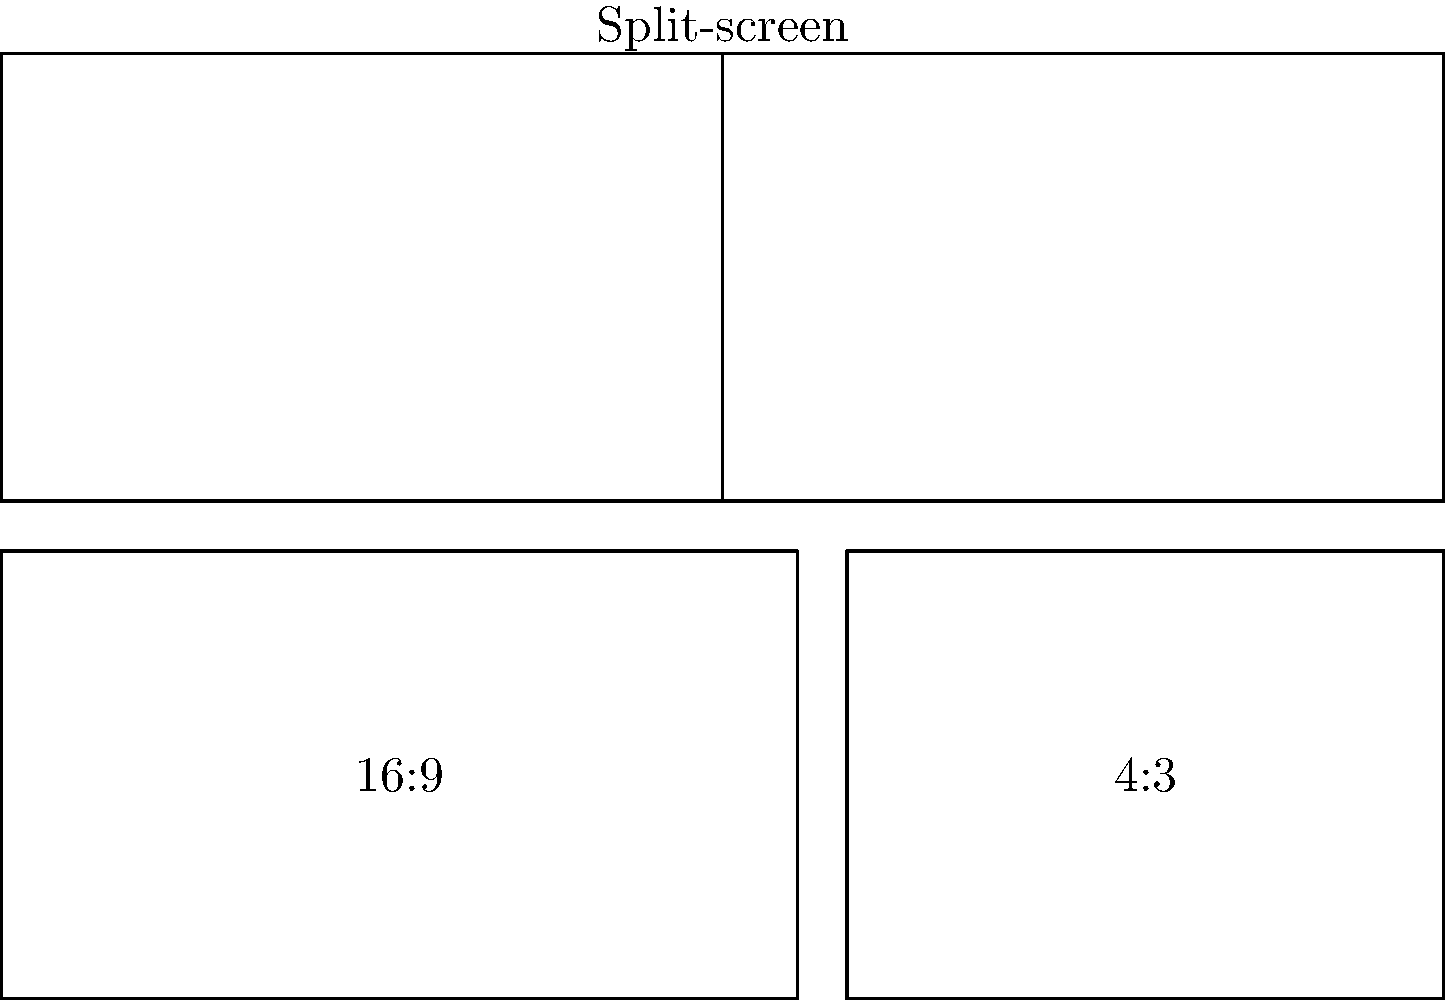In a split-screen composition using both 16:9 and 4:3 aspect ratios, how might the juxtaposition of these formats impact the visual narrative, particularly in an independent film context? Consider the potential for emphasizing character relationships or contrasting environments. To answer this question, let's break down the impact of using different aspect ratios in a split-screen composition:

1. Visual contrast: The 16:9 and 4:3 aspect ratios create a noticeable visual difference, immediately drawing attention to the split-screen composition.

2. Character emphasis: The wider 16:9 format can be used to show a character in a more expansive environment, while the 4:3 format might create a sense of confinement or focus for another character.

3. Temporal juxtaposition: Different aspect ratios can suggest different time periods, with 4:3 potentially indicating a flashback or older footage.

4. Narrative layering: The contrast in aspect ratios can represent different perspectives or realities within the story.

5. Emotional resonance: The wider 16:9 frame might convey a sense of freedom or possibility, while the 4:3 frame could evoke nostalgia or limitation.

6. Compositional balance: The filmmaker must consider how to balance the visual weight of the two different aspect ratios within the frame.

7. Thematic reinforcement: The aspect ratio choices can reinforce themes of duality, conflict, or parallel narratives in the film.

8. Audience engagement: The unique visual presentation encourages active viewing and interpretation from the audience.

9. Technical considerations: The filmmaker must plan for how these different aspect ratios will be integrated in post-production and displayed on various screens.

10. Indie film context: This technique can serve as a cost-effective way to create visual interest and complexity, aligning with independent film budgets and experimental approaches.
Answer: The juxtaposition of 16:9 and 4:3 aspect ratios in a split-screen composition can enhance visual storytelling by creating contrast, emphasizing character differences, suggesting temporal shifts, layering narratives, evoking emotions, and reinforcing themes, while engaging audiences in a unique visual experience suitable for independent film contexts. 